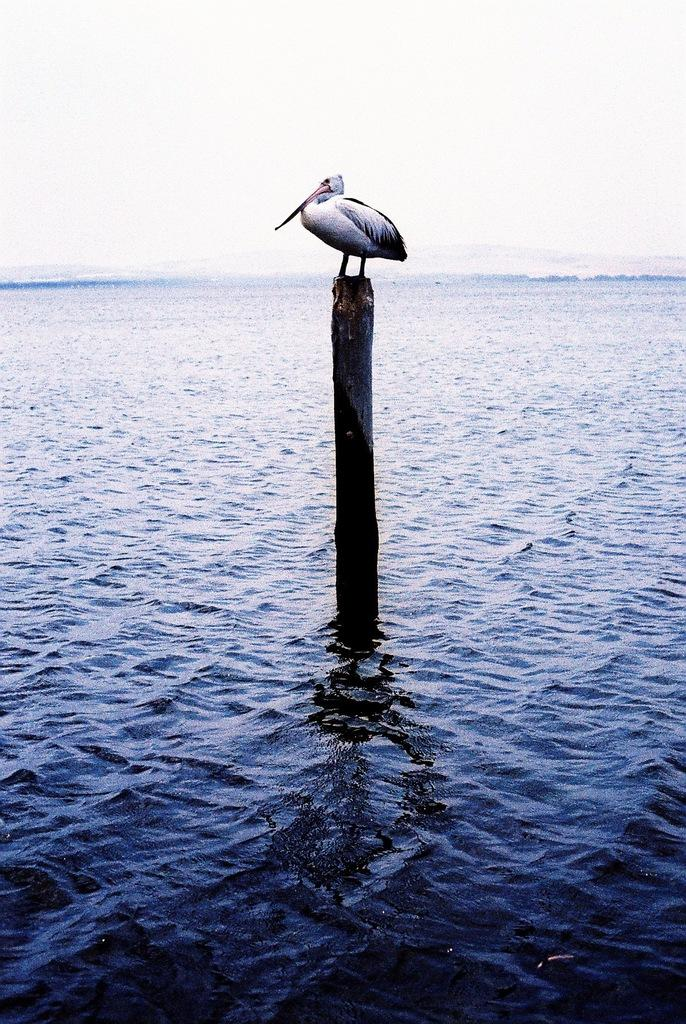What is on the pole in the image? There is a bird on a pole in the image. What can be seen in the image besides the bird on the pole? Water is visible in the image. What is visible in the background of the image? The sky is visible in the background of the image. What type of shoes is the bird wearing in the image? Birds do not wear shoes, so there is no mention of shoes in the image. 